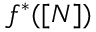<formula> <loc_0><loc_0><loc_500><loc_500>f ^ { * } ( [ N ] )</formula> 